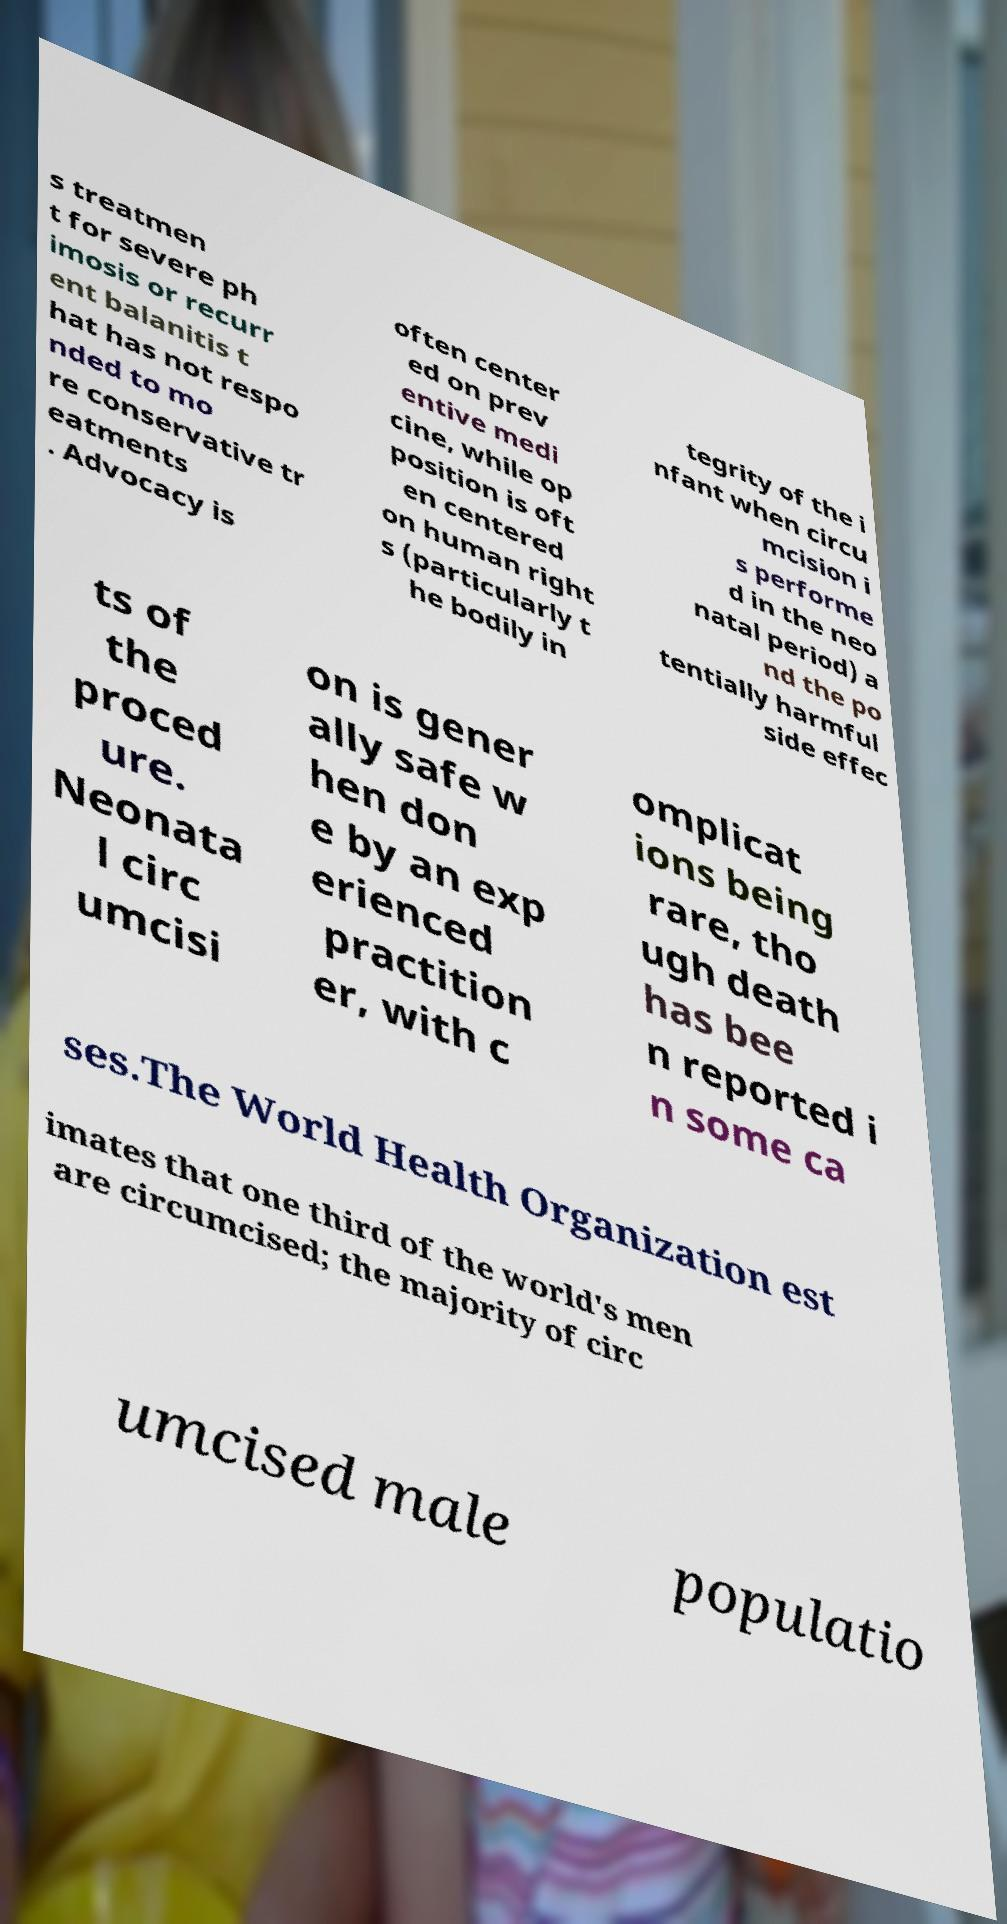Can you accurately transcribe the text from the provided image for me? s treatmen t for severe ph imosis or recurr ent balanitis t hat has not respo nded to mo re conservative tr eatments . Advocacy is often center ed on prev entive medi cine, while op position is oft en centered on human right s (particularly t he bodily in tegrity of the i nfant when circu mcision i s performe d in the neo natal period) a nd the po tentially harmful side effec ts of the proced ure. Neonata l circ umcisi on is gener ally safe w hen don e by an exp erienced practition er, with c omplicat ions being rare, tho ugh death has bee n reported i n some ca ses.The World Health Organization est imates that one third of the world's men are circumcised; the majority of circ umcised male populatio 